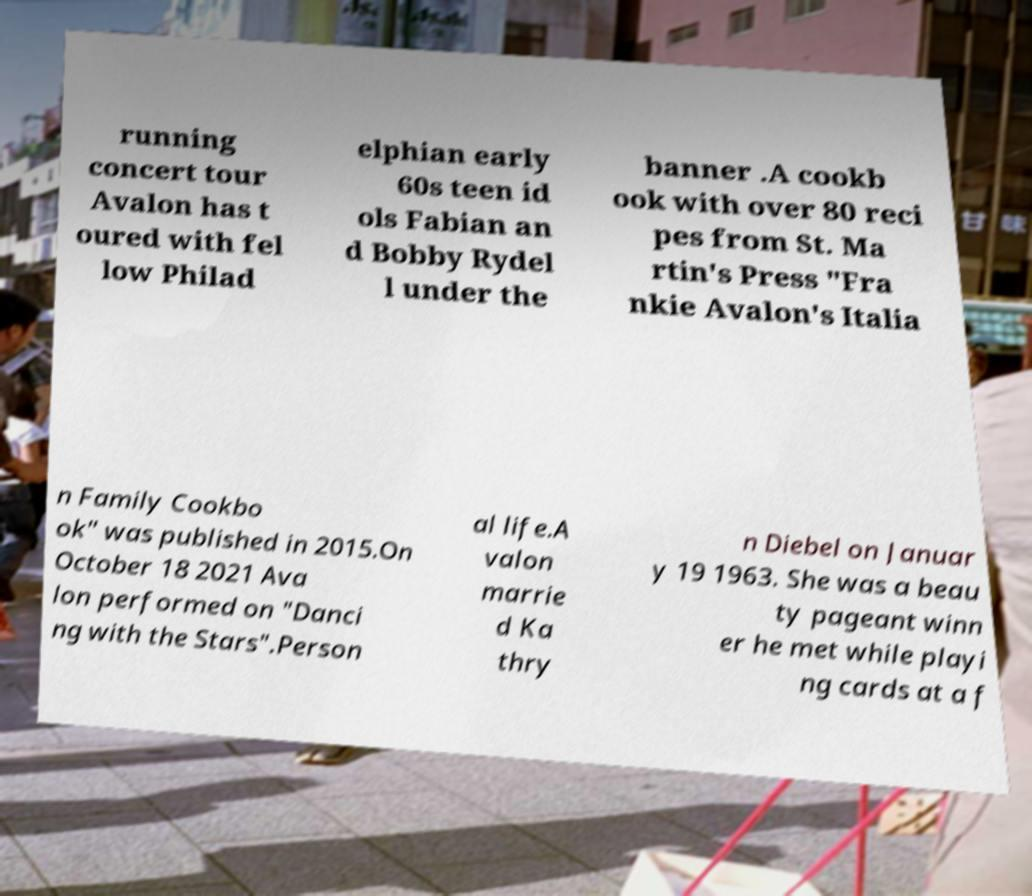What messages or text are displayed in this image? I need them in a readable, typed format. running concert tour Avalon has t oured with fel low Philad elphian early 60s teen id ols Fabian an d Bobby Rydel l under the banner .A cookb ook with over 80 reci pes from St. Ma rtin's Press "Fra nkie Avalon's Italia n Family Cookbo ok" was published in 2015.On October 18 2021 Ava lon performed on "Danci ng with the Stars".Person al life.A valon marrie d Ka thry n Diebel on Januar y 19 1963. She was a beau ty pageant winn er he met while playi ng cards at a f 